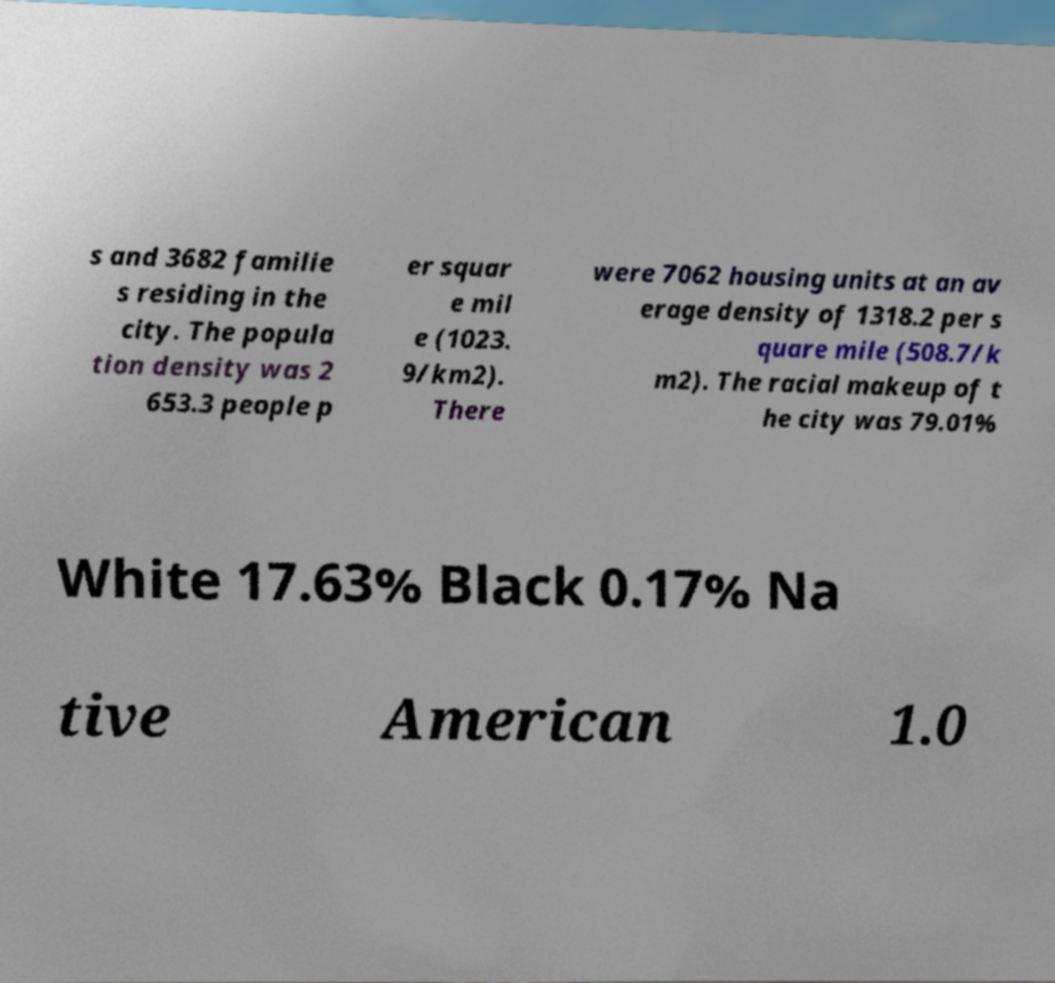Could you extract and type out the text from this image? s and 3682 familie s residing in the city. The popula tion density was 2 653.3 people p er squar e mil e (1023. 9/km2). There were 7062 housing units at an av erage density of 1318.2 per s quare mile (508.7/k m2). The racial makeup of t he city was 79.01% White 17.63% Black 0.17% Na tive American 1.0 